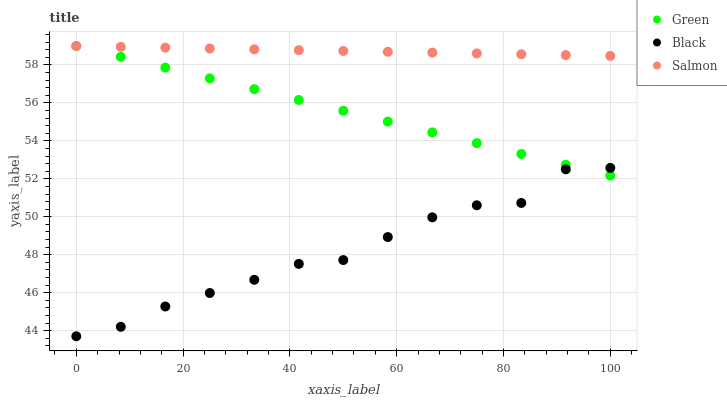Does Black have the minimum area under the curve?
Answer yes or no. Yes. Does Salmon have the maximum area under the curve?
Answer yes or no. Yes. Does Green have the minimum area under the curve?
Answer yes or no. No. Does Green have the maximum area under the curve?
Answer yes or no. No. Is Salmon the smoothest?
Answer yes or no. Yes. Is Black the roughest?
Answer yes or no. Yes. Is Green the smoothest?
Answer yes or no. No. Is Green the roughest?
Answer yes or no. No. Does Black have the lowest value?
Answer yes or no. Yes. Does Green have the lowest value?
Answer yes or no. No. Does Salmon have the highest value?
Answer yes or no. Yes. Is Black less than Salmon?
Answer yes or no. Yes. Is Salmon greater than Black?
Answer yes or no. Yes. Does Green intersect Salmon?
Answer yes or no. Yes. Is Green less than Salmon?
Answer yes or no. No. Is Green greater than Salmon?
Answer yes or no. No. Does Black intersect Salmon?
Answer yes or no. No. 